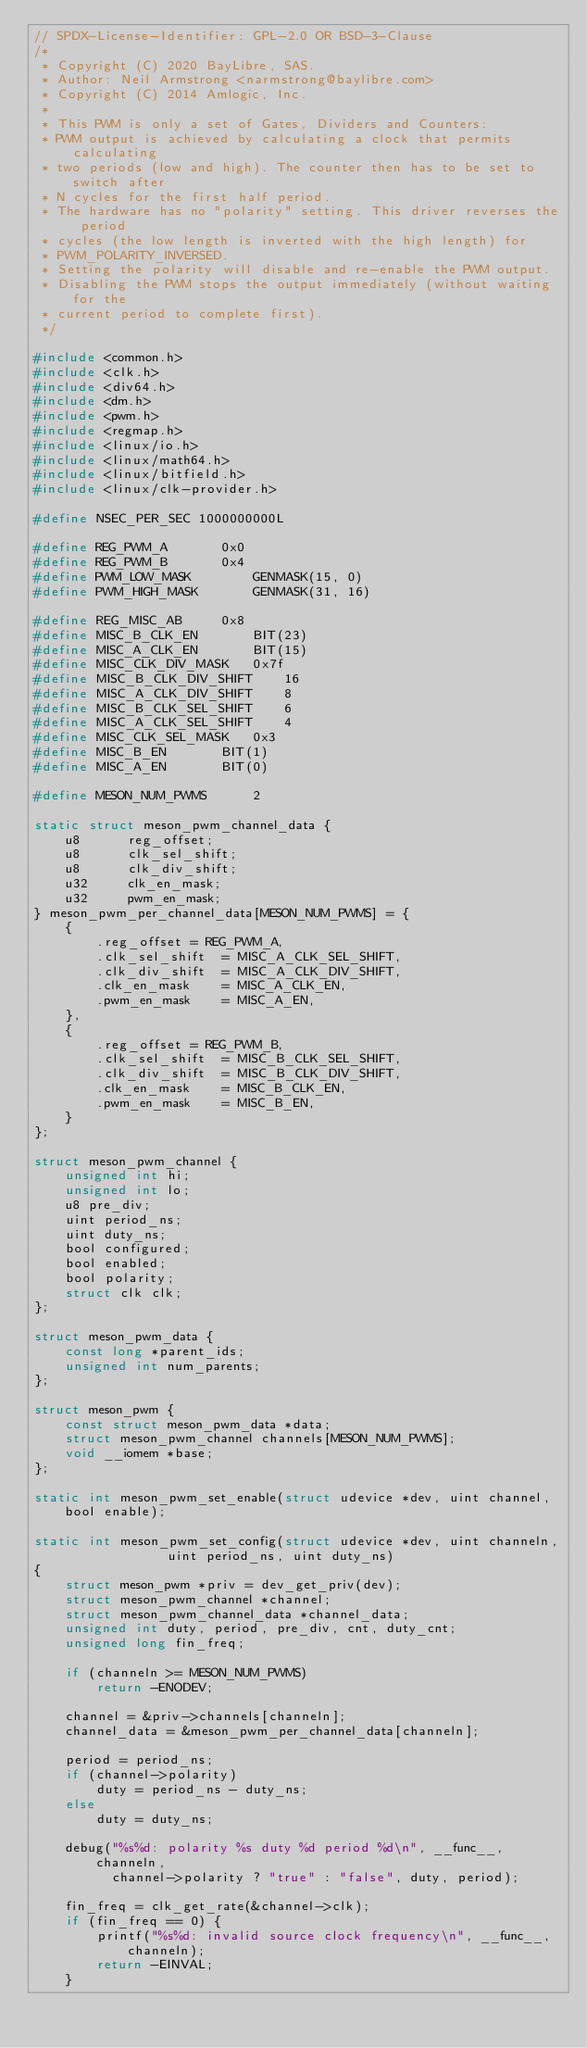<code> <loc_0><loc_0><loc_500><loc_500><_C_>// SPDX-License-Identifier: GPL-2.0 OR BSD-3-Clause
/*
 * Copyright (C) 2020 BayLibre, SAS.
 * Author: Neil Armstrong <narmstrong@baylibre.com>
 * Copyright (C) 2014 Amlogic, Inc.
 *
 * This PWM is only a set of Gates, Dividers and Counters:
 * PWM output is achieved by calculating a clock that permits calculating
 * two periods (low and high). The counter then has to be set to switch after
 * N cycles for the first half period.
 * The hardware has no "polarity" setting. This driver reverses the period
 * cycles (the low length is inverted with the high length) for
 * PWM_POLARITY_INVERSED.
 * Setting the polarity will disable and re-enable the PWM output.
 * Disabling the PWM stops the output immediately (without waiting for the
 * current period to complete first).
 */

#include <common.h>
#include <clk.h>
#include <div64.h>
#include <dm.h>
#include <pwm.h>
#include <regmap.h>
#include <linux/io.h>
#include <linux/math64.h>
#include <linux/bitfield.h>
#include <linux/clk-provider.h>

#define NSEC_PER_SEC 1000000000L

#define REG_PWM_A		0x0
#define REG_PWM_B		0x4
#define PWM_LOW_MASK		GENMASK(15, 0)
#define PWM_HIGH_MASK		GENMASK(31, 16)

#define REG_MISC_AB		0x8
#define MISC_B_CLK_EN		BIT(23)
#define MISC_A_CLK_EN		BIT(15)
#define MISC_CLK_DIV_MASK	0x7f
#define MISC_B_CLK_DIV_SHIFT	16
#define MISC_A_CLK_DIV_SHIFT	8
#define MISC_B_CLK_SEL_SHIFT	6
#define MISC_A_CLK_SEL_SHIFT	4
#define MISC_CLK_SEL_MASK	0x3
#define MISC_B_EN		BIT(1)
#define MISC_A_EN		BIT(0)

#define MESON_NUM_PWMS		2

static struct meson_pwm_channel_data {
	u8		reg_offset;
	u8		clk_sel_shift;
	u8		clk_div_shift;
	u32		clk_en_mask;
	u32		pwm_en_mask;
} meson_pwm_per_channel_data[MESON_NUM_PWMS] = {
	{
		.reg_offset	= REG_PWM_A,
		.clk_sel_shift	= MISC_A_CLK_SEL_SHIFT,
		.clk_div_shift	= MISC_A_CLK_DIV_SHIFT,
		.clk_en_mask	= MISC_A_CLK_EN,
		.pwm_en_mask	= MISC_A_EN,
	},
	{
		.reg_offset	= REG_PWM_B,
		.clk_sel_shift	= MISC_B_CLK_SEL_SHIFT,
		.clk_div_shift	= MISC_B_CLK_DIV_SHIFT,
		.clk_en_mask	= MISC_B_CLK_EN,
		.pwm_en_mask	= MISC_B_EN,
	}
};

struct meson_pwm_channel {
	unsigned int hi;
	unsigned int lo;
	u8 pre_div;
	uint period_ns;
	uint duty_ns;
	bool configured;
	bool enabled;
	bool polarity;
	struct clk clk;
};

struct meson_pwm_data {
	const long *parent_ids;
	unsigned int num_parents;
};

struct meson_pwm {
	const struct meson_pwm_data *data;
	struct meson_pwm_channel channels[MESON_NUM_PWMS];
	void __iomem *base;
};

static int meson_pwm_set_enable(struct udevice *dev, uint channel, bool enable);

static int meson_pwm_set_config(struct udevice *dev, uint channeln,
				 uint period_ns, uint duty_ns)
{
	struct meson_pwm *priv = dev_get_priv(dev);
	struct meson_pwm_channel *channel;
	struct meson_pwm_channel_data *channel_data;
	unsigned int duty, period, pre_div, cnt, duty_cnt;
	unsigned long fin_freq;

	if (channeln >= MESON_NUM_PWMS)
		return -ENODEV;

	channel = &priv->channels[channeln];
	channel_data = &meson_pwm_per_channel_data[channeln];

	period = period_ns;
	if (channel->polarity)
		duty = period_ns - duty_ns;
	else
		duty = duty_ns;

	debug("%s%d: polarity %s duty %d period %d\n", __func__, channeln,
	      channel->polarity ? "true" : "false", duty, period);

	fin_freq = clk_get_rate(&channel->clk);
	if (fin_freq == 0) {
		printf("%s%d: invalid source clock frequency\n", __func__, channeln);
		return -EINVAL;
	}
</code> 